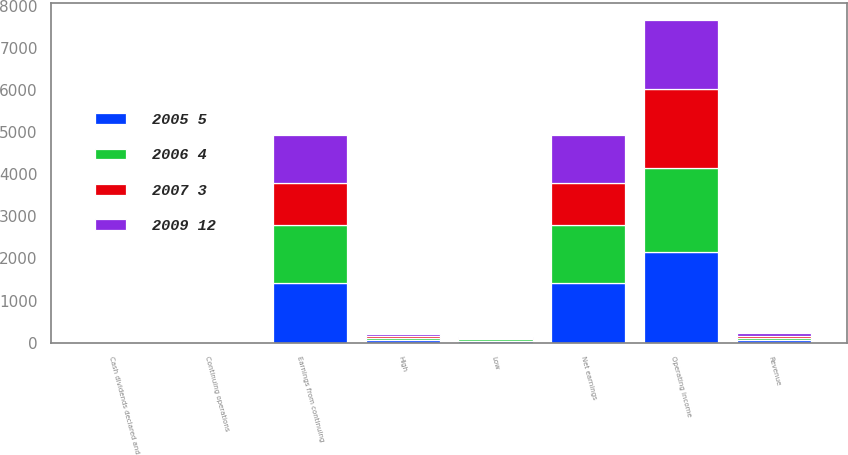Convert chart. <chart><loc_0><loc_0><loc_500><loc_500><stacked_bar_chart><ecel><fcel>Revenue<fcel>Operating income<fcel>Earnings from continuing<fcel>Net earnings<fcel>Continuing operations<fcel>Cash dividends declared and<fcel>High<fcel>Low<nl><fcel>2007 3<fcel>54.95<fcel>1870<fcel>1003<fcel>1003<fcel>2.39<fcel>0.54<fcel>48.03<fcel>16.42<nl><fcel>2005 5<fcel>54.95<fcel>2161<fcel>1407<fcel>1407<fcel>3.12<fcel>0.46<fcel>53.9<fcel>41.85<nl><fcel>2006 4<fcel>54.95<fcel>1999<fcel>1377<fcel>1377<fcel>2.79<fcel>0.36<fcel>59.5<fcel>43.51<nl><fcel>2009 12<fcel>54.95<fcel>1644<fcel>1140<fcel>1140<fcel>2.27<fcel>0.31<fcel>56<fcel>31.93<nl></chart> 